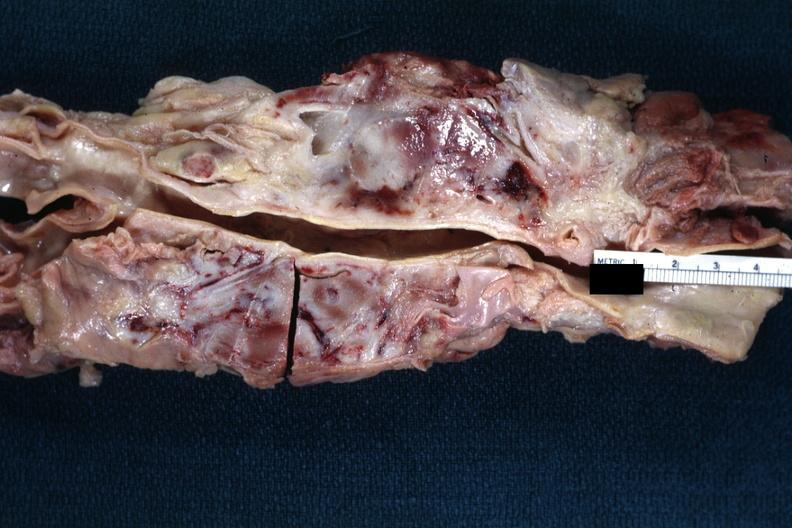does feet show matted and fused periaortic nodes with hemorrhagic necrosis good example?
Answer the question using a single word or phrase. No 